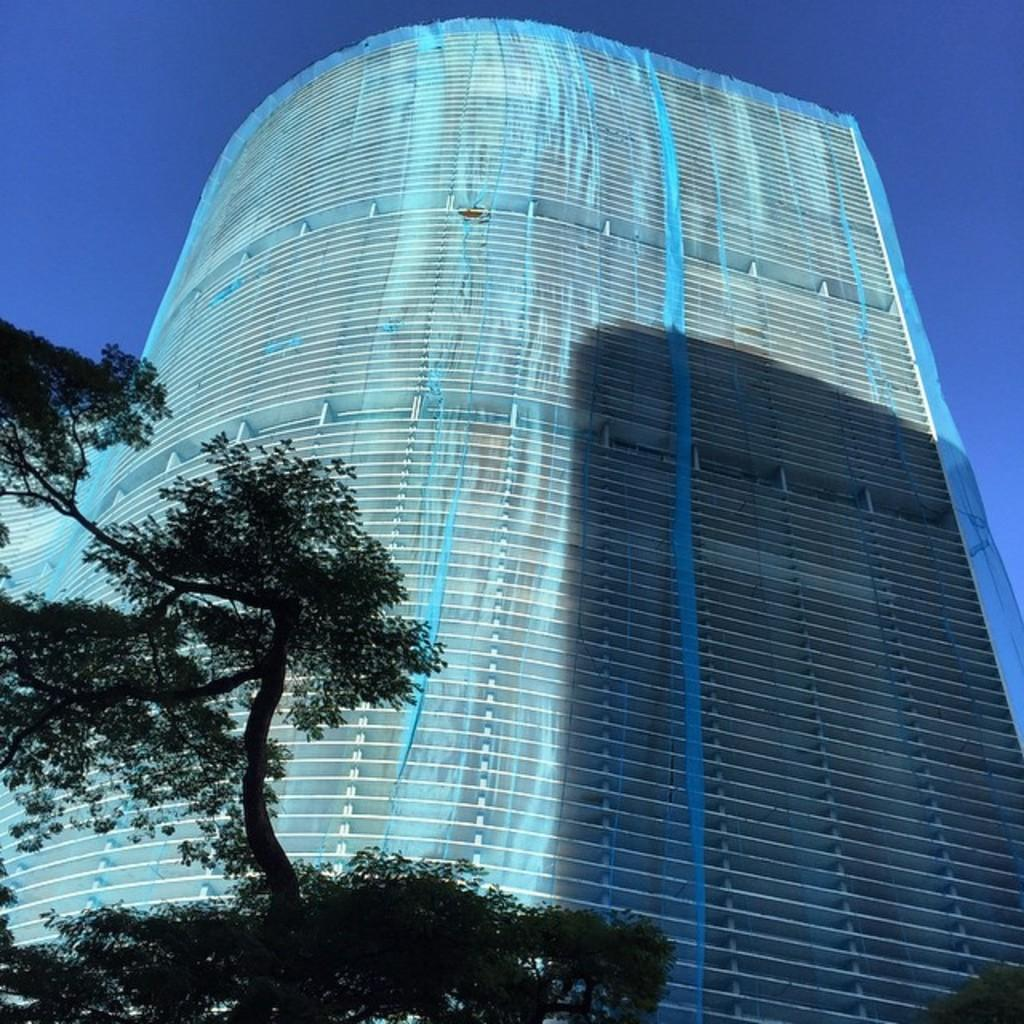What type of plant can be seen in the image? There is a tree in the image. What is located behind the tree? There is a tall building with many floors behind the tree. What can be seen at the top of the building? The sky is visible at the top of the building. What type of attraction is visible in the image? There is no attraction present in the image; it features a tree and a tall building with many-building. What type of growth can be seen on the tree in the image? The image does not show any specific growth on the tree, as it is not focused on the details of the tree's appearance. 